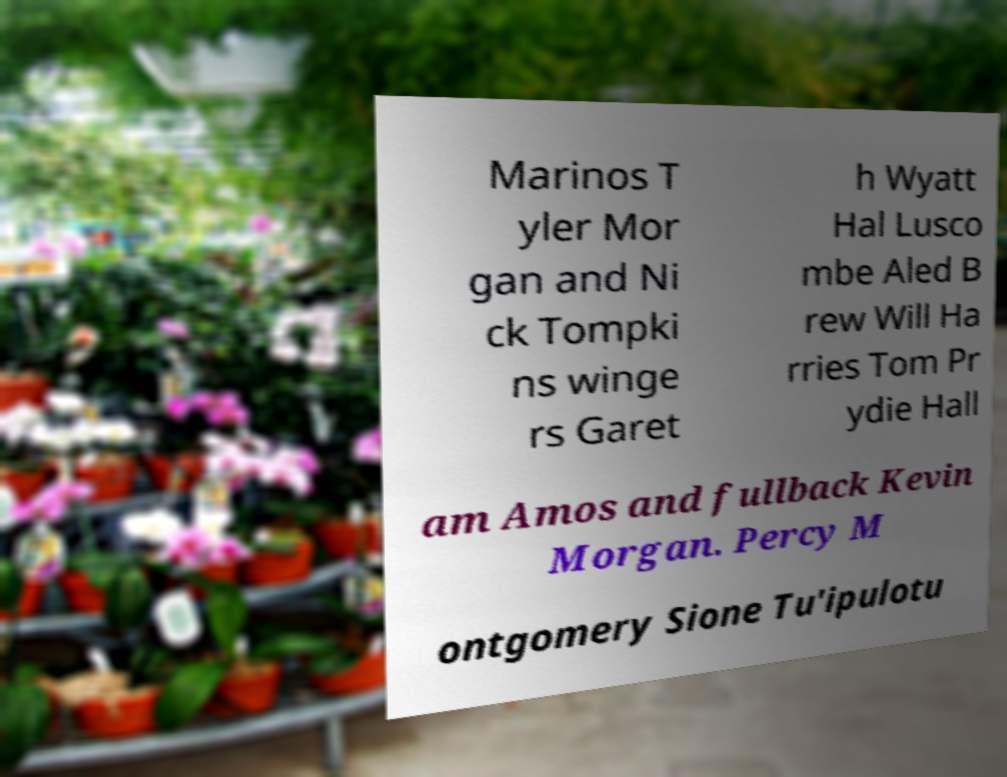Can you accurately transcribe the text from the provided image for me? Marinos T yler Mor gan and Ni ck Tompki ns winge rs Garet h Wyatt Hal Lusco mbe Aled B rew Will Ha rries Tom Pr ydie Hall am Amos and fullback Kevin Morgan. Percy M ontgomery Sione Tu'ipulotu 